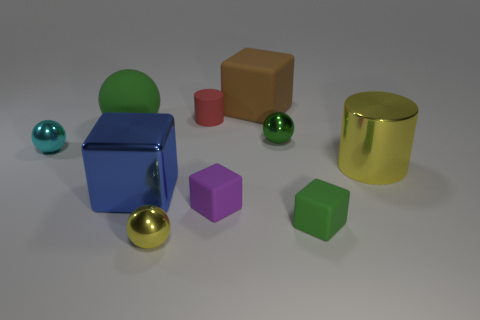Subtract all purple cylinders. How many green balls are left? 2 Subtract all green cubes. How many cubes are left? 3 Subtract all big brown blocks. How many blocks are left? 3 Subtract all blue spheres. Subtract all gray cylinders. How many spheres are left? 4 Subtract all cylinders. How many objects are left? 8 Add 1 small cyan shiny balls. How many small cyan shiny balls are left? 2 Add 3 tiny purple metallic blocks. How many tiny purple metallic blocks exist? 3 Subtract 0 red spheres. How many objects are left? 10 Subtract all large yellow shiny objects. Subtract all tiny green rubber things. How many objects are left? 8 